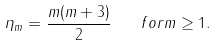<formula> <loc_0><loc_0><loc_500><loc_500>\eta _ { m } = \frac { m ( m + 3 ) } { 2 } \quad f o r m \geq 1 .</formula> 